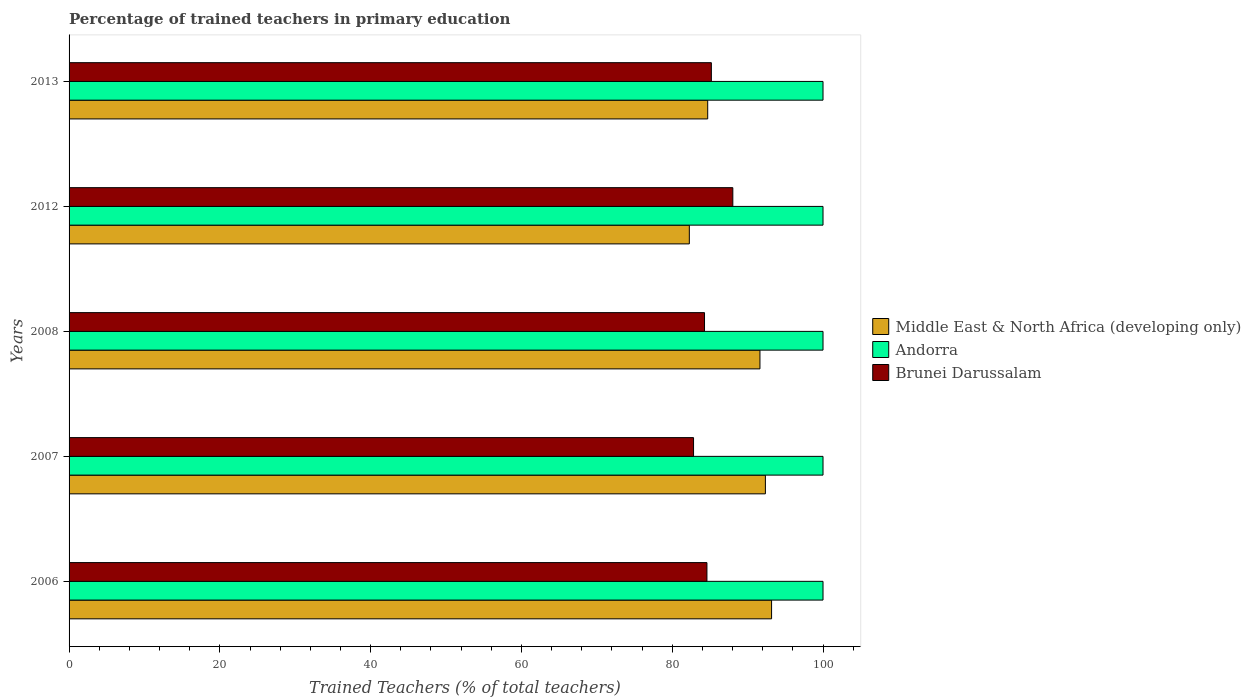How many different coloured bars are there?
Make the answer very short. 3. Are the number of bars on each tick of the Y-axis equal?
Your answer should be compact. Yes. Across all years, what is the maximum percentage of trained teachers in Middle East & North Africa (developing only)?
Ensure brevity in your answer.  93.18. Across all years, what is the minimum percentage of trained teachers in Brunei Darussalam?
Ensure brevity in your answer.  82.83. What is the total percentage of trained teachers in Andorra in the graph?
Keep it short and to the point. 500. What is the difference between the percentage of trained teachers in Andorra in 2008 and that in 2013?
Your answer should be very brief. 0. What is the difference between the percentage of trained teachers in Andorra in 2007 and the percentage of trained teachers in Brunei Darussalam in 2013?
Give a very brief answer. 14.81. What is the average percentage of trained teachers in Andorra per year?
Provide a short and direct response. 100. In the year 2007, what is the difference between the percentage of trained teachers in Andorra and percentage of trained teachers in Middle East & North Africa (developing only)?
Your answer should be very brief. 7.64. In how many years, is the percentage of trained teachers in Brunei Darussalam greater than 64 %?
Offer a terse response. 5. What is the ratio of the percentage of trained teachers in Brunei Darussalam in 2008 to that in 2013?
Ensure brevity in your answer.  0.99. Is the percentage of trained teachers in Brunei Darussalam in 2012 less than that in 2013?
Ensure brevity in your answer.  No. Is the difference between the percentage of trained teachers in Andorra in 2006 and 2013 greater than the difference between the percentage of trained teachers in Middle East & North Africa (developing only) in 2006 and 2013?
Offer a terse response. No. What is the difference between the highest and the second highest percentage of trained teachers in Brunei Darussalam?
Provide a short and direct response. 2.85. What is the difference between the highest and the lowest percentage of trained teachers in Brunei Darussalam?
Provide a succinct answer. 5.21. What does the 3rd bar from the top in 2008 represents?
Your answer should be compact. Middle East & North Africa (developing only). What does the 1st bar from the bottom in 2008 represents?
Provide a succinct answer. Middle East & North Africa (developing only). Does the graph contain any zero values?
Provide a short and direct response. No. Where does the legend appear in the graph?
Provide a short and direct response. Center right. What is the title of the graph?
Provide a short and direct response. Percentage of trained teachers in primary education. What is the label or title of the X-axis?
Provide a short and direct response. Trained Teachers (% of total teachers). What is the Trained Teachers (% of total teachers) of Middle East & North Africa (developing only) in 2006?
Provide a succinct answer. 93.18. What is the Trained Teachers (% of total teachers) in Brunei Darussalam in 2006?
Provide a short and direct response. 84.6. What is the Trained Teachers (% of total teachers) in Middle East & North Africa (developing only) in 2007?
Provide a short and direct response. 92.36. What is the Trained Teachers (% of total teachers) of Brunei Darussalam in 2007?
Ensure brevity in your answer.  82.83. What is the Trained Teachers (% of total teachers) in Middle East & North Africa (developing only) in 2008?
Give a very brief answer. 91.64. What is the Trained Teachers (% of total teachers) in Brunei Darussalam in 2008?
Your answer should be compact. 84.28. What is the Trained Teachers (% of total teachers) in Middle East & North Africa (developing only) in 2012?
Your answer should be very brief. 82.27. What is the Trained Teachers (% of total teachers) in Andorra in 2012?
Provide a succinct answer. 100. What is the Trained Teachers (% of total teachers) of Brunei Darussalam in 2012?
Make the answer very short. 88.04. What is the Trained Teachers (% of total teachers) in Middle East & North Africa (developing only) in 2013?
Your answer should be compact. 84.71. What is the Trained Teachers (% of total teachers) of Andorra in 2013?
Provide a short and direct response. 100. What is the Trained Teachers (% of total teachers) of Brunei Darussalam in 2013?
Provide a succinct answer. 85.19. Across all years, what is the maximum Trained Teachers (% of total teachers) in Middle East & North Africa (developing only)?
Provide a succinct answer. 93.18. Across all years, what is the maximum Trained Teachers (% of total teachers) of Brunei Darussalam?
Offer a terse response. 88.04. Across all years, what is the minimum Trained Teachers (% of total teachers) of Middle East & North Africa (developing only)?
Make the answer very short. 82.27. Across all years, what is the minimum Trained Teachers (% of total teachers) in Andorra?
Ensure brevity in your answer.  100. Across all years, what is the minimum Trained Teachers (% of total teachers) in Brunei Darussalam?
Your response must be concise. 82.83. What is the total Trained Teachers (% of total teachers) in Middle East & North Africa (developing only) in the graph?
Offer a very short reply. 444.14. What is the total Trained Teachers (% of total teachers) in Andorra in the graph?
Offer a very short reply. 500. What is the total Trained Teachers (% of total teachers) of Brunei Darussalam in the graph?
Provide a succinct answer. 424.95. What is the difference between the Trained Teachers (% of total teachers) of Middle East & North Africa (developing only) in 2006 and that in 2007?
Ensure brevity in your answer.  0.82. What is the difference between the Trained Teachers (% of total teachers) of Brunei Darussalam in 2006 and that in 2007?
Offer a terse response. 1.78. What is the difference between the Trained Teachers (% of total teachers) in Middle East & North Africa (developing only) in 2006 and that in 2008?
Provide a short and direct response. 1.54. What is the difference between the Trained Teachers (% of total teachers) in Brunei Darussalam in 2006 and that in 2008?
Provide a succinct answer. 0.32. What is the difference between the Trained Teachers (% of total teachers) in Middle East & North Africa (developing only) in 2006 and that in 2012?
Provide a succinct answer. 10.91. What is the difference between the Trained Teachers (% of total teachers) in Brunei Darussalam in 2006 and that in 2012?
Your answer should be compact. -3.43. What is the difference between the Trained Teachers (% of total teachers) in Middle East & North Africa (developing only) in 2006 and that in 2013?
Keep it short and to the point. 8.47. What is the difference between the Trained Teachers (% of total teachers) in Andorra in 2006 and that in 2013?
Give a very brief answer. 0. What is the difference between the Trained Teachers (% of total teachers) in Brunei Darussalam in 2006 and that in 2013?
Provide a succinct answer. -0.59. What is the difference between the Trained Teachers (% of total teachers) of Middle East & North Africa (developing only) in 2007 and that in 2008?
Your answer should be compact. 0.72. What is the difference between the Trained Teachers (% of total teachers) in Brunei Darussalam in 2007 and that in 2008?
Give a very brief answer. -1.46. What is the difference between the Trained Teachers (% of total teachers) in Middle East & North Africa (developing only) in 2007 and that in 2012?
Make the answer very short. 10.09. What is the difference between the Trained Teachers (% of total teachers) of Andorra in 2007 and that in 2012?
Your answer should be compact. 0. What is the difference between the Trained Teachers (% of total teachers) of Brunei Darussalam in 2007 and that in 2012?
Keep it short and to the point. -5.21. What is the difference between the Trained Teachers (% of total teachers) of Middle East & North Africa (developing only) in 2007 and that in 2013?
Provide a succinct answer. 7.65. What is the difference between the Trained Teachers (% of total teachers) of Andorra in 2007 and that in 2013?
Your response must be concise. 0. What is the difference between the Trained Teachers (% of total teachers) of Brunei Darussalam in 2007 and that in 2013?
Offer a terse response. -2.36. What is the difference between the Trained Teachers (% of total teachers) of Middle East & North Africa (developing only) in 2008 and that in 2012?
Provide a succinct answer. 9.37. What is the difference between the Trained Teachers (% of total teachers) of Andorra in 2008 and that in 2012?
Give a very brief answer. 0. What is the difference between the Trained Teachers (% of total teachers) of Brunei Darussalam in 2008 and that in 2012?
Offer a terse response. -3.75. What is the difference between the Trained Teachers (% of total teachers) of Middle East & North Africa (developing only) in 2008 and that in 2013?
Your answer should be compact. 6.93. What is the difference between the Trained Teachers (% of total teachers) in Brunei Darussalam in 2008 and that in 2013?
Make the answer very short. -0.91. What is the difference between the Trained Teachers (% of total teachers) of Middle East & North Africa (developing only) in 2012 and that in 2013?
Offer a terse response. -2.44. What is the difference between the Trained Teachers (% of total teachers) of Brunei Darussalam in 2012 and that in 2013?
Provide a succinct answer. 2.85. What is the difference between the Trained Teachers (% of total teachers) in Middle East & North Africa (developing only) in 2006 and the Trained Teachers (% of total teachers) in Andorra in 2007?
Offer a terse response. -6.82. What is the difference between the Trained Teachers (% of total teachers) of Middle East & North Africa (developing only) in 2006 and the Trained Teachers (% of total teachers) of Brunei Darussalam in 2007?
Offer a terse response. 10.35. What is the difference between the Trained Teachers (% of total teachers) of Andorra in 2006 and the Trained Teachers (% of total teachers) of Brunei Darussalam in 2007?
Your answer should be very brief. 17.17. What is the difference between the Trained Teachers (% of total teachers) of Middle East & North Africa (developing only) in 2006 and the Trained Teachers (% of total teachers) of Andorra in 2008?
Provide a succinct answer. -6.82. What is the difference between the Trained Teachers (% of total teachers) of Middle East & North Africa (developing only) in 2006 and the Trained Teachers (% of total teachers) of Brunei Darussalam in 2008?
Give a very brief answer. 8.89. What is the difference between the Trained Teachers (% of total teachers) of Andorra in 2006 and the Trained Teachers (% of total teachers) of Brunei Darussalam in 2008?
Keep it short and to the point. 15.72. What is the difference between the Trained Teachers (% of total teachers) of Middle East & North Africa (developing only) in 2006 and the Trained Teachers (% of total teachers) of Andorra in 2012?
Offer a very short reply. -6.82. What is the difference between the Trained Teachers (% of total teachers) in Middle East & North Africa (developing only) in 2006 and the Trained Teachers (% of total teachers) in Brunei Darussalam in 2012?
Your answer should be very brief. 5.14. What is the difference between the Trained Teachers (% of total teachers) in Andorra in 2006 and the Trained Teachers (% of total teachers) in Brunei Darussalam in 2012?
Your answer should be very brief. 11.96. What is the difference between the Trained Teachers (% of total teachers) in Middle East & North Africa (developing only) in 2006 and the Trained Teachers (% of total teachers) in Andorra in 2013?
Offer a terse response. -6.82. What is the difference between the Trained Teachers (% of total teachers) of Middle East & North Africa (developing only) in 2006 and the Trained Teachers (% of total teachers) of Brunei Darussalam in 2013?
Give a very brief answer. 7.99. What is the difference between the Trained Teachers (% of total teachers) of Andorra in 2006 and the Trained Teachers (% of total teachers) of Brunei Darussalam in 2013?
Provide a short and direct response. 14.81. What is the difference between the Trained Teachers (% of total teachers) in Middle East & North Africa (developing only) in 2007 and the Trained Teachers (% of total teachers) in Andorra in 2008?
Your answer should be compact. -7.64. What is the difference between the Trained Teachers (% of total teachers) of Middle East & North Africa (developing only) in 2007 and the Trained Teachers (% of total teachers) of Brunei Darussalam in 2008?
Ensure brevity in your answer.  8.07. What is the difference between the Trained Teachers (% of total teachers) in Andorra in 2007 and the Trained Teachers (% of total teachers) in Brunei Darussalam in 2008?
Give a very brief answer. 15.72. What is the difference between the Trained Teachers (% of total teachers) in Middle East & North Africa (developing only) in 2007 and the Trained Teachers (% of total teachers) in Andorra in 2012?
Your answer should be very brief. -7.64. What is the difference between the Trained Teachers (% of total teachers) of Middle East & North Africa (developing only) in 2007 and the Trained Teachers (% of total teachers) of Brunei Darussalam in 2012?
Offer a very short reply. 4.32. What is the difference between the Trained Teachers (% of total teachers) in Andorra in 2007 and the Trained Teachers (% of total teachers) in Brunei Darussalam in 2012?
Provide a succinct answer. 11.96. What is the difference between the Trained Teachers (% of total teachers) in Middle East & North Africa (developing only) in 2007 and the Trained Teachers (% of total teachers) in Andorra in 2013?
Your answer should be compact. -7.64. What is the difference between the Trained Teachers (% of total teachers) of Middle East & North Africa (developing only) in 2007 and the Trained Teachers (% of total teachers) of Brunei Darussalam in 2013?
Your answer should be very brief. 7.17. What is the difference between the Trained Teachers (% of total teachers) of Andorra in 2007 and the Trained Teachers (% of total teachers) of Brunei Darussalam in 2013?
Your answer should be very brief. 14.81. What is the difference between the Trained Teachers (% of total teachers) in Middle East & North Africa (developing only) in 2008 and the Trained Teachers (% of total teachers) in Andorra in 2012?
Give a very brief answer. -8.36. What is the difference between the Trained Teachers (% of total teachers) of Middle East & North Africa (developing only) in 2008 and the Trained Teachers (% of total teachers) of Brunei Darussalam in 2012?
Ensure brevity in your answer.  3.6. What is the difference between the Trained Teachers (% of total teachers) of Andorra in 2008 and the Trained Teachers (% of total teachers) of Brunei Darussalam in 2012?
Provide a short and direct response. 11.96. What is the difference between the Trained Teachers (% of total teachers) in Middle East & North Africa (developing only) in 2008 and the Trained Teachers (% of total teachers) in Andorra in 2013?
Your response must be concise. -8.36. What is the difference between the Trained Teachers (% of total teachers) in Middle East & North Africa (developing only) in 2008 and the Trained Teachers (% of total teachers) in Brunei Darussalam in 2013?
Offer a very short reply. 6.45. What is the difference between the Trained Teachers (% of total teachers) in Andorra in 2008 and the Trained Teachers (% of total teachers) in Brunei Darussalam in 2013?
Offer a terse response. 14.81. What is the difference between the Trained Teachers (% of total teachers) of Middle East & North Africa (developing only) in 2012 and the Trained Teachers (% of total teachers) of Andorra in 2013?
Ensure brevity in your answer.  -17.73. What is the difference between the Trained Teachers (% of total teachers) of Middle East & North Africa (developing only) in 2012 and the Trained Teachers (% of total teachers) of Brunei Darussalam in 2013?
Make the answer very short. -2.92. What is the difference between the Trained Teachers (% of total teachers) in Andorra in 2012 and the Trained Teachers (% of total teachers) in Brunei Darussalam in 2013?
Provide a short and direct response. 14.81. What is the average Trained Teachers (% of total teachers) in Middle East & North Africa (developing only) per year?
Offer a very short reply. 88.83. What is the average Trained Teachers (% of total teachers) of Brunei Darussalam per year?
Provide a succinct answer. 84.99. In the year 2006, what is the difference between the Trained Teachers (% of total teachers) in Middle East & North Africa (developing only) and Trained Teachers (% of total teachers) in Andorra?
Provide a succinct answer. -6.82. In the year 2006, what is the difference between the Trained Teachers (% of total teachers) of Middle East & North Africa (developing only) and Trained Teachers (% of total teachers) of Brunei Darussalam?
Give a very brief answer. 8.57. In the year 2006, what is the difference between the Trained Teachers (% of total teachers) of Andorra and Trained Teachers (% of total teachers) of Brunei Darussalam?
Keep it short and to the point. 15.4. In the year 2007, what is the difference between the Trained Teachers (% of total teachers) in Middle East & North Africa (developing only) and Trained Teachers (% of total teachers) in Andorra?
Offer a terse response. -7.64. In the year 2007, what is the difference between the Trained Teachers (% of total teachers) in Middle East & North Africa (developing only) and Trained Teachers (% of total teachers) in Brunei Darussalam?
Your answer should be very brief. 9.53. In the year 2007, what is the difference between the Trained Teachers (% of total teachers) in Andorra and Trained Teachers (% of total teachers) in Brunei Darussalam?
Your response must be concise. 17.17. In the year 2008, what is the difference between the Trained Teachers (% of total teachers) of Middle East & North Africa (developing only) and Trained Teachers (% of total teachers) of Andorra?
Offer a terse response. -8.36. In the year 2008, what is the difference between the Trained Teachers (% of total teachers) in Middle East & North Africa (developing only) and Trained Teachers (% of total teachers) in Brunei Darussalam?
Provide a succinct answer. 7.35. In the year 2008, what is the difference between the Trained Teachers (% of total teachers) in Andorra and Trained Teachers (% of total teachers) in Brunei Darussalam?
Give a very brief answer. 15.72. In the year 2012, what is the difference between the Trained Teachers (% of total teachers) of Middle East & North Africa (developing only) and Trained Teachers (% of total teachers) of Andorra?
Provide a short and direct response. -17.73. In the year 2012, what is the difference between the Trained Teachers (% of total teachers) in Middle East & North Africa (developing only) and Trained Teachers (% of total teachers) in Brunei Darussalam?
Make the answer very short. -5.77. In the year 2012, what is the difference between the Trained Teachers (% of total teachers) in Andorra and Trained Teachers (% of total teachers) in Brunei Darussalam?
Provide a short and direct response. 11.96. In the year 2013, what is the difference between the Trained Teachers (% of total teachers) in Middle East & North Africa (developing only) and Trained Teachers (% of total teachers) in Andorra?
Provide a succinct answer. -15.29. In the year 2013, what is the difference between the Trained Teachers (% of total teachers) of Middle East & North Africa (developing only) and Trained Teachers (% of total teachers) of Brunei Darussalam?
Provide a succinct answer. -0.49. In the year 2013, what is the difference between the Trained Teachers (% of total teachers) of Andorra and Trained Teachers (% of total teachers) of Brunei Darussalam?
Ensure brevity in your answer.  14.81. What is the ratio of the Trained Teachers (% of total teachers) in Middle East & North Africa (developing only) in 2006 to that in 2007?
Your answer should be very brief. 1.01. What is the ratio of the Trained Teachers (% of total teachers) in Andorra in 2006 to that in 2007?
Give a very brief answer. 1. What is the ratio of the Trained Teachers (% of total teachers) of Brunei Darussalam in 2006 to that in 2007?
Your answer should be compact. 1.02. What is the ratio of the Trained Teachers (% of total teachers) in Middle East & North Africa (developing only) in 2006 to that in 2008?
Your answer should be compact. 1.02. What is the ratio of the Trained Teachers (% of total teachers) of Andorra in 2006 to that in 2008?
Make the answer very short. 1. What is the ratio of the Trained Teachers (% of total teachers) in Brunei Darussalam in 2006 to that in 2008?
Your answer should be compact. 1. What is the ratio of the Trained Teachers (% of total teachers) of Middle East & North Africa (developing only) in 2006 to that in 2012?
Your answer should be very brief. 1.13. What is the ratio of the Trained Teachers (% of total teachers) in Andorra in 2006 to that in 2012?
Offer a very short reply. 1. What is the ratio of the Trained Teachers (% of total teachers) of Middle East & North Africa (developing only) in 2006 to that in 2013?
Provide a short and direct response. 1.1. What is the ratio of the Trained Teachers (% of total teachers) of Andorra in 2006 to that in 2013?
Provide a short and direct response. 1. What is the ratio of the Trained Teachers (% of total teachers) in Brunei Darussalam in 2006 to that in 2013?
Your answer should be very brief. 0.99. What is the ratio of the Trained Teachers (% of total teachers) of Middle East & North Africa (developing only) in 2007 to that in 2008?
Provide a short and direct response. 1.01. What is the ratio of the Trained Teachers (% of total teachers) in Brunei Darussalam in 2007 to that in 2008?
Keep it short and to the point. 0.98. What is the ratio of the Trained Teachers (% of total teachers) of Middle East & North Africa (developing only) in 2007 to that in 2012?
Your response must be concise. 1.12. What is the ratio of the Trained Teachers (% of total teachers) of Brunei Darussalam in 2007 to that in 2012?
Your response must be concise. 0.94. What is the ratio of the Trained Teachers (% of total teachers) in Middle East & North Africa (developing only) in 2007 to that in 2013?
Make the answer very short. 1.09. What is the ratio of the Trained Teachers (% of total teachers) of Andorra in 2007 to that in 2013?
Your answer should be compact. 1. What is the ratio of the Trained Teachers (% of total teachers) of Brunei Darussalam in 2007 to that in 2013?
Ensure brevity in your answer.  0.97. What is the ratio of the Trained Teachers (% of total teachers) of Middle East & North Africa (developing only) in 2008 to that in 2012?
Give a very brief answer. 1.11. What is the ratio of the Trained Teachers (% of total teachers) in Andorra in 2008 to that in 2012?
Make the answer very short. 1. What is the ratio of the Trained Teachers (% of total teachers) of Brunei Darussalam in 2008 to that in 2012?
Make the answer very short. 0.96. What is the ratio of the Trained Teachers (% of total teachers) in Middle East & North Africa (developing only) in 2008 to that in 2013?
Your answer should be very brief. 1.08. What is the ratio of the Trained Teachers (% of total teachers) in Brunei Darussalam in 2008 to that in 2013?
Provide a short and direct response. 0.99. What is the ratio of the Trained Teachers (% of total teachers) in Middle East & North Africa (developing only) in 2012 to that in 2013?
Make the answer very short. 0.97. What is the ratio of the Trained Teachers (% of total teachers) in Andorra in 2012 to that in 2013?
Keep it short and to the point. 1. What is the ratio of the Trained Teachers (% of total teachers) in Brunei Darussalam in 2012 to that in 2013?
Your response must be concise. 1.03. What is the difference between the highest and the second highest Trained Teachers (% of total teachers) in Middle East & North Africa (developing only)?
Keep it short and to the point. 0.82. What is the difference between the highest and the second highest Trained Teachers (% of total teachers) of Andorra?
Offer a terse response. 0. What is the difference between the highest and the second highest Trained Teachers (% of total teachers) in Brunei Darussalam?
Keep it short and to the point. 2.85. What is the difference between the highest and the lowest Trained Teachers (% of total teachers) of Middle East & North Africa (developing only)?
Your response must be concise. 10.91. What is the difference between the highest and the lowest Trained Teachers (% of total teachers) of Andorra?
Your response must be concise. 0. What is the difference between the highest and the lowest Trained Teachers (% of total teachers) in Brunei Darussalam?
Give a very brief answer. 5.21. 